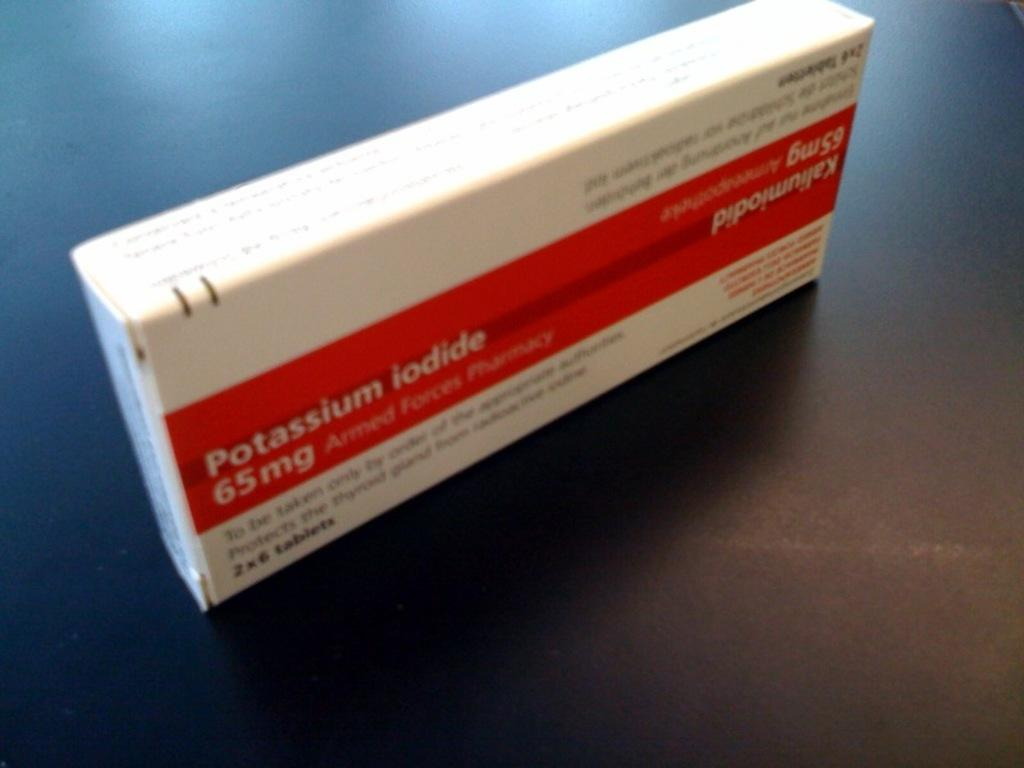Provide a one-sentence caption for the provided image. a red and white box of potassium iodide. 